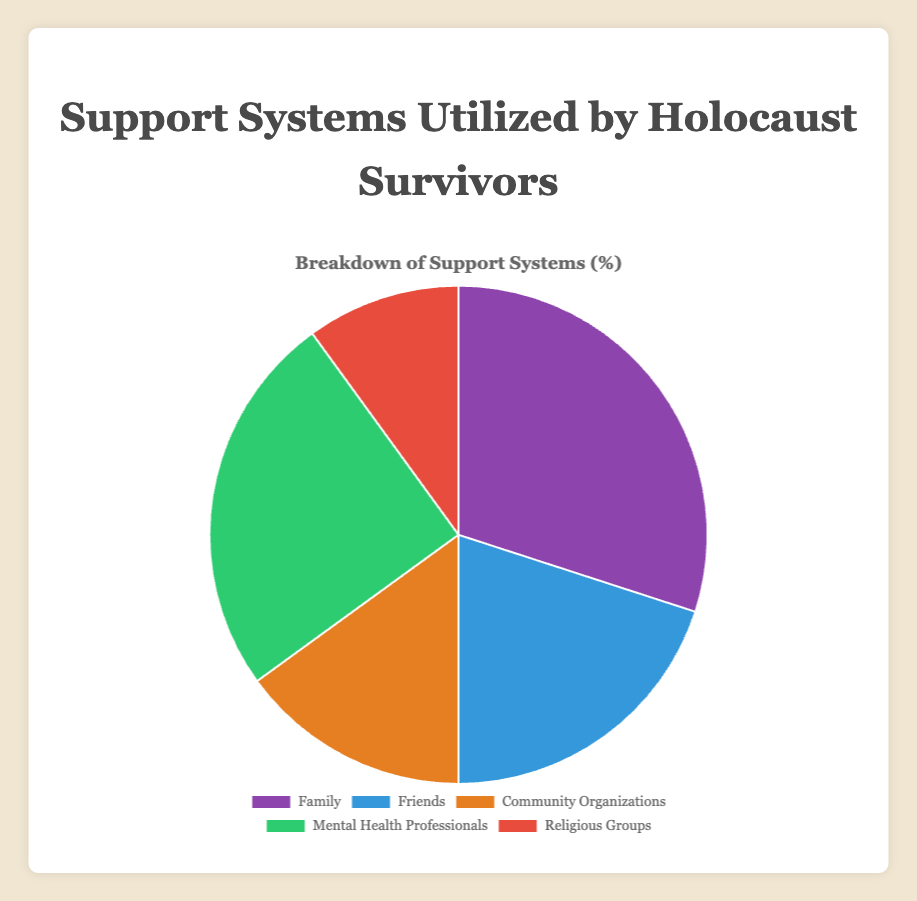What percentage of Holocaust survivors utilize community organizations as a support system? The figure shows that the segment representing community organizations on the pie chart is labeled with a specific percentage. Looking at this label reveals that community organizations are utilized by 15% of Holocaust survivors.
Answer: 15% Which support system is utilized by the smallest percentage of Holocaust survivors? To identify this, we examine each segment of the pie chart and compare the percentages. The segment with the smallest percentage is for religious groups, which has 10%.
Answer: Religious groups What is the total percentage of Holocaust survivors utilizing family and friends as their support systems? The pie chart labels indicate that family is utilized by 30% and friends by 20%. Summing these values gives 30% + 20% = 50%.
Answer: 50% How much more, percentage-wise, do Holocaust survivors utilize family over community organizations? We need to find the difference between the percentages for family and community organizations. Family is utilized by 30% and community organizations by 15%. The difference is 30% - 15% = 15%.
Answer: 15% Which support system is utilized by a higher percentage: mental health professionals or friends? Comparing the labels for mental health professionals and friends, we see that mental health professionals are utilized by 25% while friends are utilized by 20%. Thus, mental health professionals are utilized by a higher percentage.
Answer: Mental health professionals What percentage of Holocaust survivors utilizes religious groups and community organizations combined? Adding the percentages for religious groups (10%) and community organizations (15%) gives us 10% + 15% = 25%.
Answer: 25% Which support system segment on the pie chart is represented by the green color? The color-coded pie chart indicates different support systems, and the green segment represents the mental health professionals.
Answer: Mental health professionals What is the average percentage utilization of all support systems for Holocaust survivors? To find the average, sum the percentages of all support systems and divide by the number of support systems. The sum is 30% + 20% + 15% + 25% + 10% = 100%. Dividing by 5, we get an average of 100%/5 = 20%.
Answer: 20% By how much does the percentage of Holocaust survivors utilizing mental health professionals exceed that of religious groups? The pie chart shows that 25% utilize mental health professionals, and 10% utilize religious groups. The difference is 25% - 10% = 15%.
Answer: 15% What is the sum of the percentages utilized by the least two frequently used support systems? Identifying the least two frequently used support systems, religious groups (10%) and community organizations (15%), their sum is 10% + 15% = 25%.
Answer: 25% 